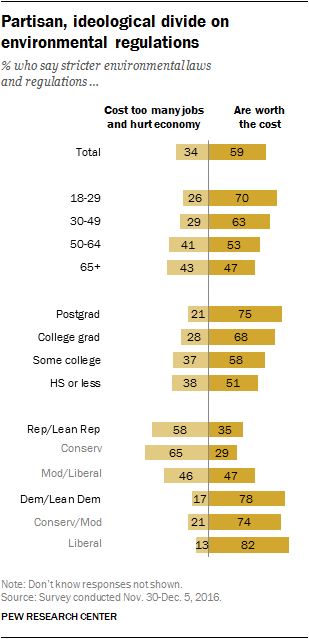List a handful of essential elements in this visual. It is clear that the 18-29 age group is most likely to choose 'worth the cost' as they are the most tech-savvy and value the convenience and efficiency that the technology offers. The democratic-leaning demographic is more likely to choose to purchase items at a higher cost, compared to the lean demographic. 